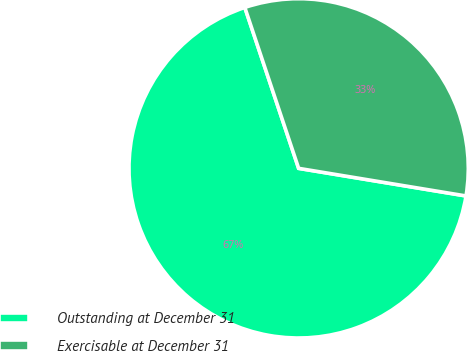<chart> <loc_0><loc_0><loc_500><loc_500><pie_chart><fcel>Outstanding at December 31<fcel>Exercisable at December 31<nl><fcel>67.26%<fcel>32.74%<nl></chart> 